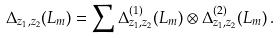<formula> <loc_0><loc_0><loc_500><loc_500>\Delta _ { z _ { 1 } , z _ { 2 } } ( L _ { m } ) = \sum \Delta _ { z _ { 1 } , z _ { 2 } } ^ { ( 1 ) } ( L _ { m } ) \otimes \Delta _ { z _ { 1 } , z _ { 2 } } ^ { ( 2 ) } ( L _ { m } ) \, .</formula> 